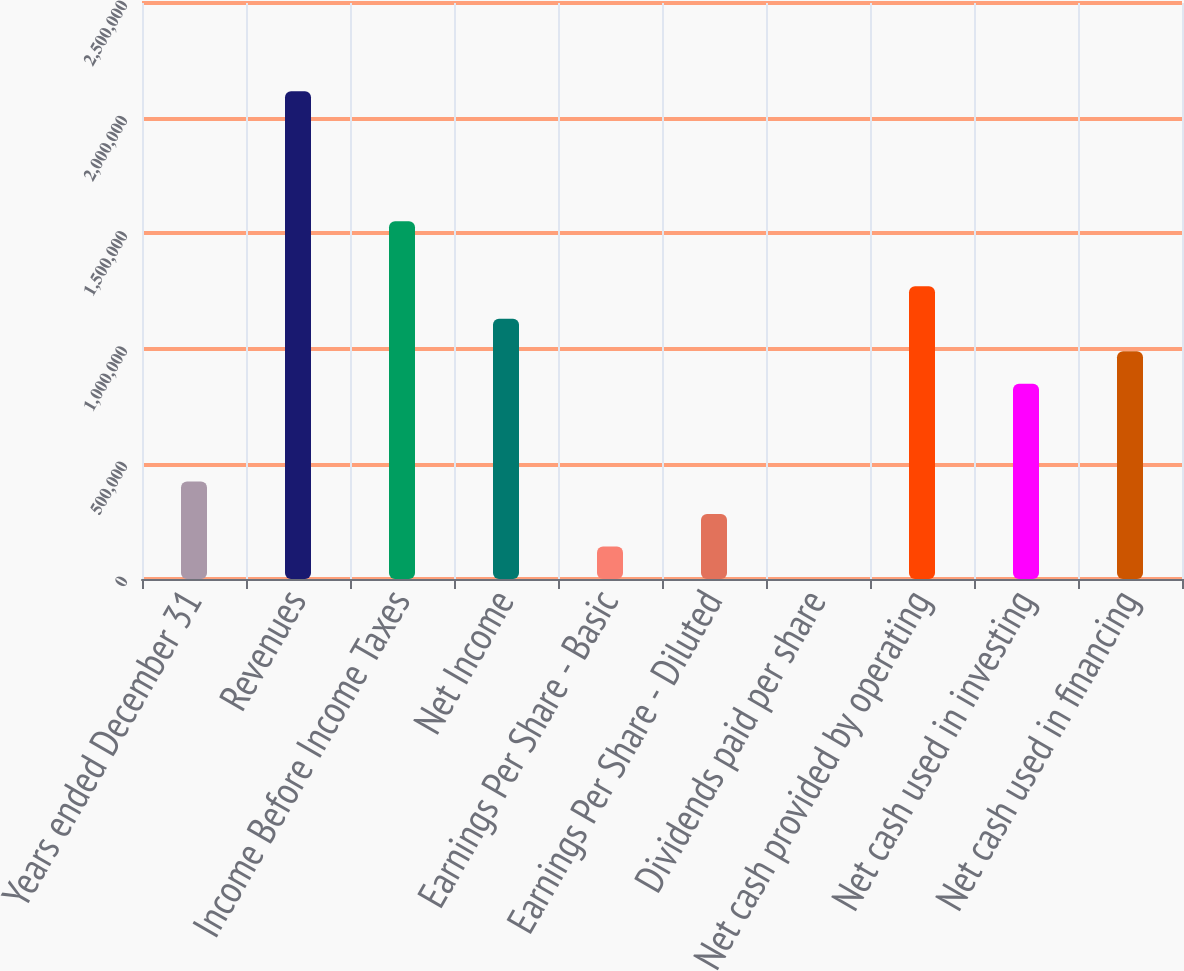Convert chart to OTSL. <chart><loc_0><loc_0><loc_500><loc_500><bar_chart><fcel>Years ended December 31<fcel>Revenues<fcel>Income Before Income Taxes<fcel>Net Income<fcel>Earnings Per Share - Basic<fcel>Earnings Per Share - Diluted<fcel>Dividends paid per share<fcel>Net cash provided by operating<fcel>Net cash used in investing<fcel>Net cash used in financing<nl><fcel>423470<fcel>2.11735e+06<fcel>1.55272e+06<fcel>1.12925e+06<fcel>141157<fcel>282313<fcel>0.35<fcel>1.27041e+06<fcel>846940<fcel>988096<nl></chart> 